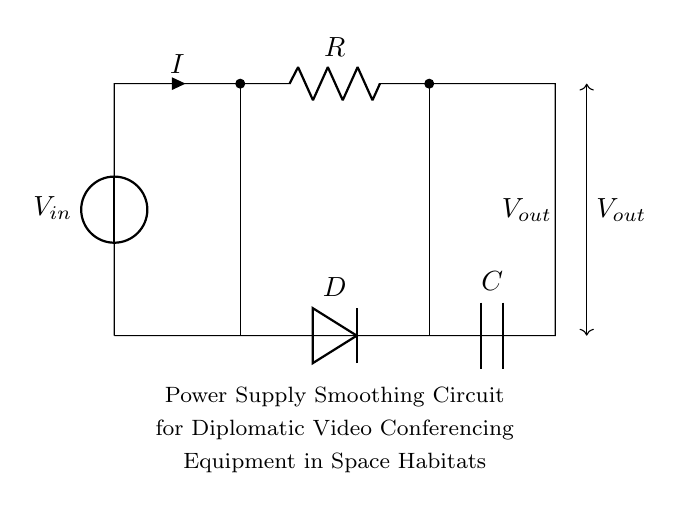What is the function of the diode in this circuit? The diode allows current to flow in one direction, protecting the circuit from reverse voltage which can damage the components.
Answer: Allow current direction What is the value of the output voltage in this power supply smoothing circuit? The output voltage is directly related to the input voltage and the characteristics of R, C, and D in the circuit; it provides a smoothed voltage after rectification.
Answer: Smoother voltage What components are present in the circuit? The circuit contains a voltage source, resistor, diode, and capacitor, each of which plays a specific role in smoothing and regulating the power supply.
Answer: Voltage source, resistor, diode, capacitor How does the capacitor contribute to power smoothing? The capacitor stores electrical energy and releases it when needed, thus smoothing out fluctuations in the output voltage caused by varying load conditions.
Answer: Stores energy, smooths voltage What type of circuit is depicted here? The circuit is an RC power supply smoothing circuit, utilizing both resistors and capacitors to manage and regulate voltage for stable performance.
Answer: RC smoothing circuit What is the purpose of the resistor in this circuit? The resistor limits the current flowing through the circuit, ensuring that the components operate within safe limits and also impacts the charging time of the capacitor.
Answer: Limits current 